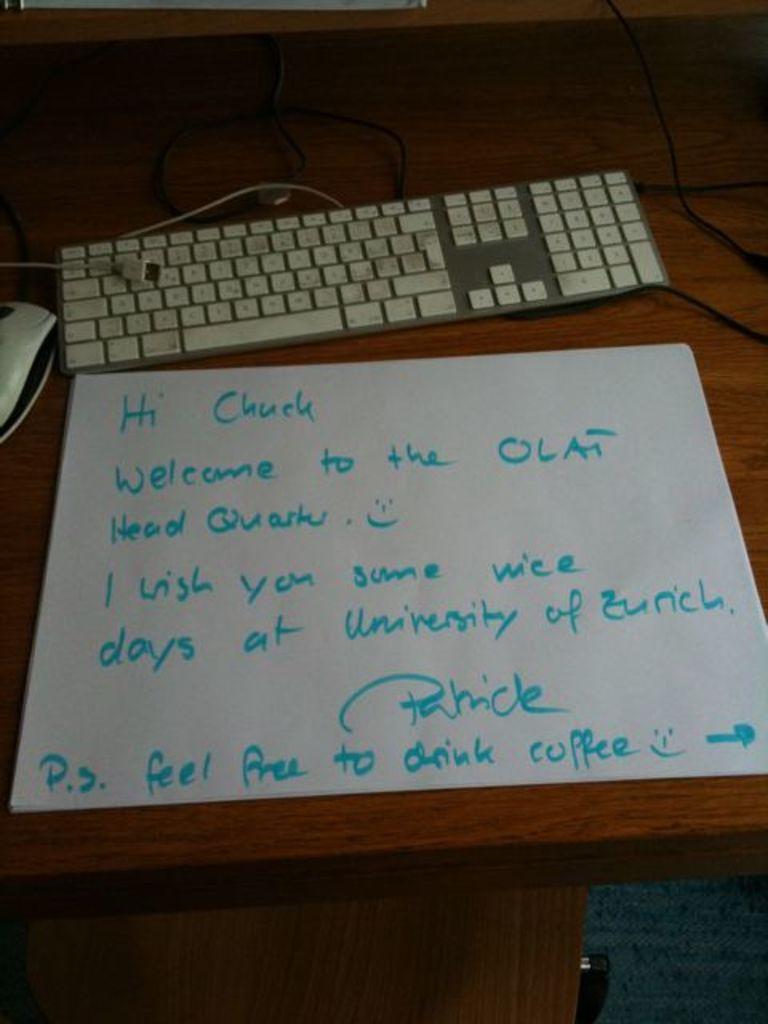Who is patrick writing to?
Ensure brevity in your answer.  Chuck. Who wrote the note to chuck?
Offer a terse response. Patrick. 